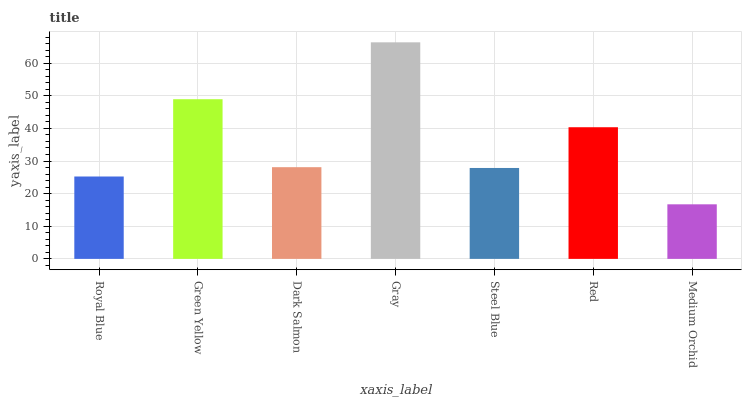Is Medium Orchid the minimum?
Answer yes or no. Yes. Is Gray the maximum?
Answer yes or no. Yes. Is Green Yellow the minimum?
Answer yes or no. No. Is Green Yellow the maximum?
Answer yes or no. No. Is Green Yellow greater than Royal Blue?
Answer yes or no. Yes. Is Royal Blue less than Green Yellow?
Answer yes or no. Yes. Is Royal Blue greater than Green Yellow?
Answer yes or no. No. Is Green Yellow less than Royal Blue?
Answer yes or no. No. Is Dark Salmon the high median?
Answer yes or no. Yes. Is Dark Salmon the low median?
Answer yes or no. Yes. Is Steel Blue the high median?
Answer yes or no. No. Is Steel Blue the low median?
Answer yes or no. No. 